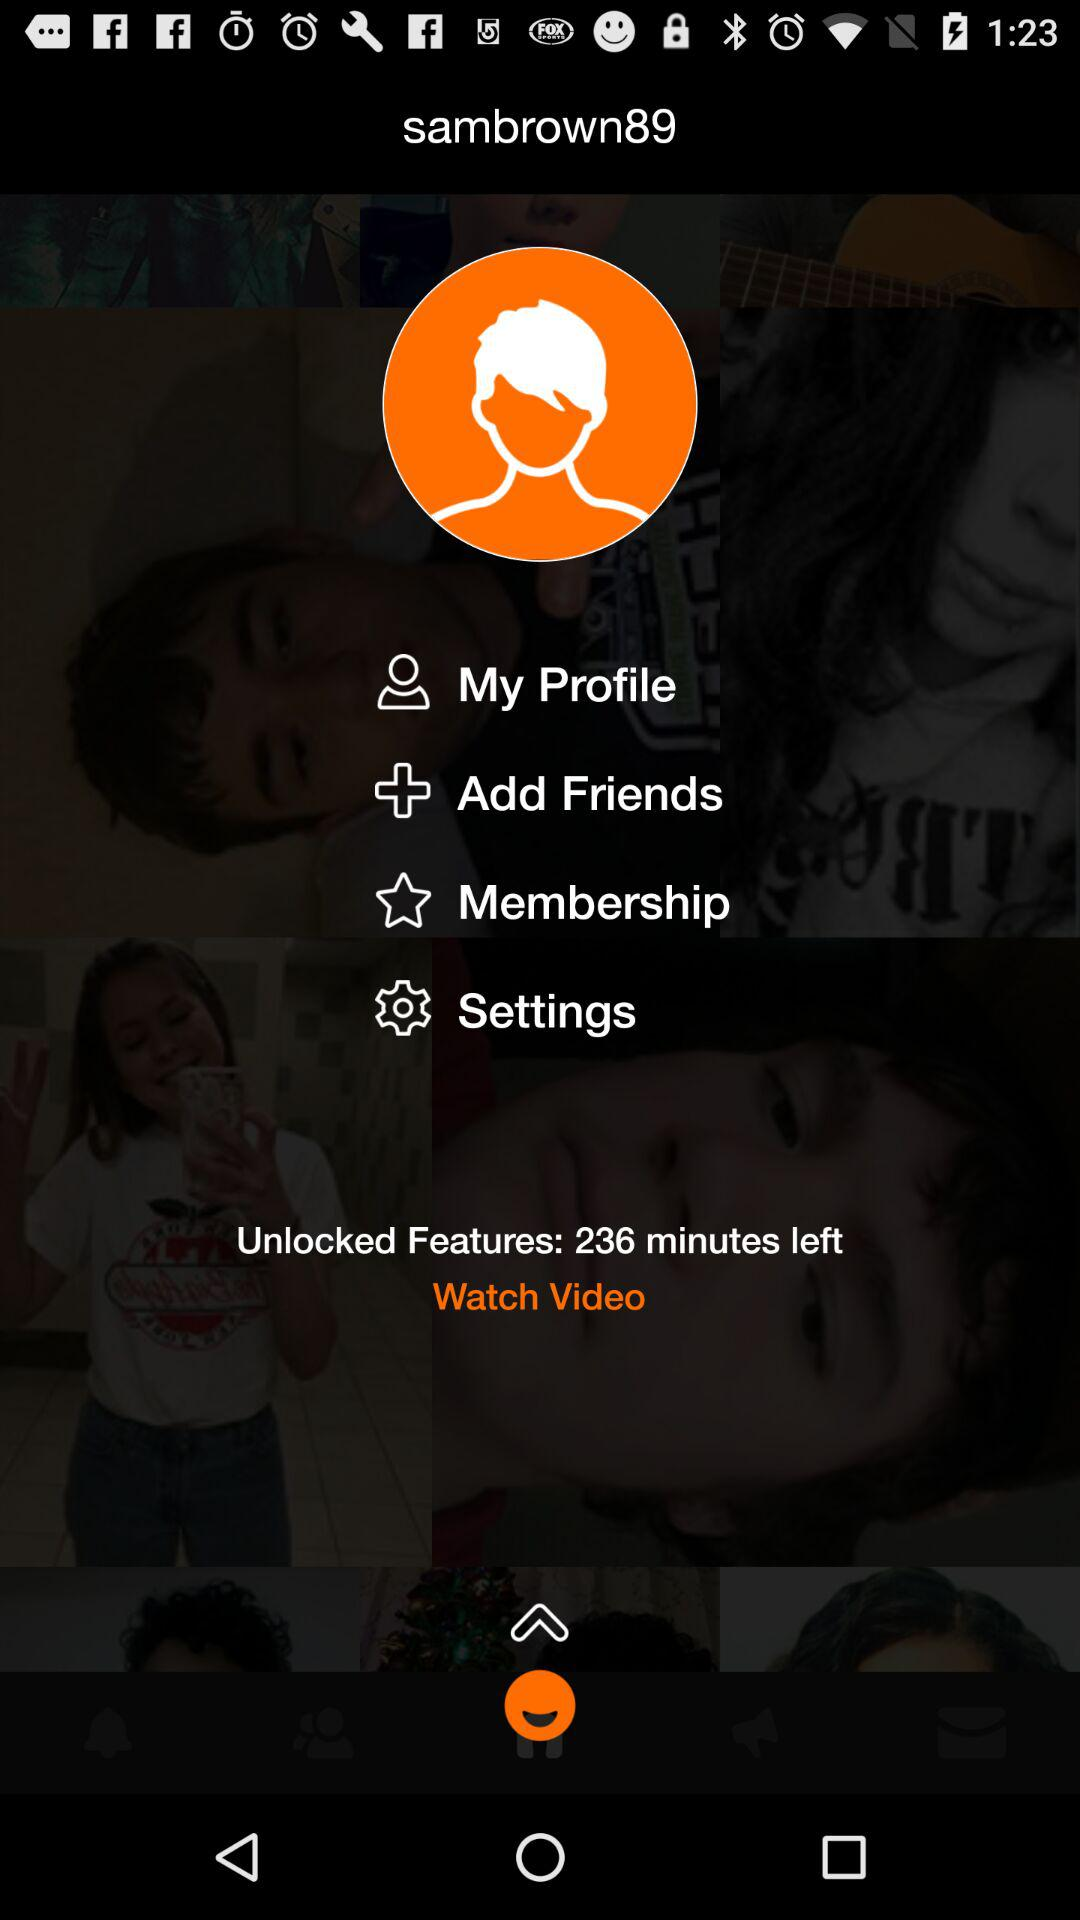What is the username? The username is "sambrown89". 